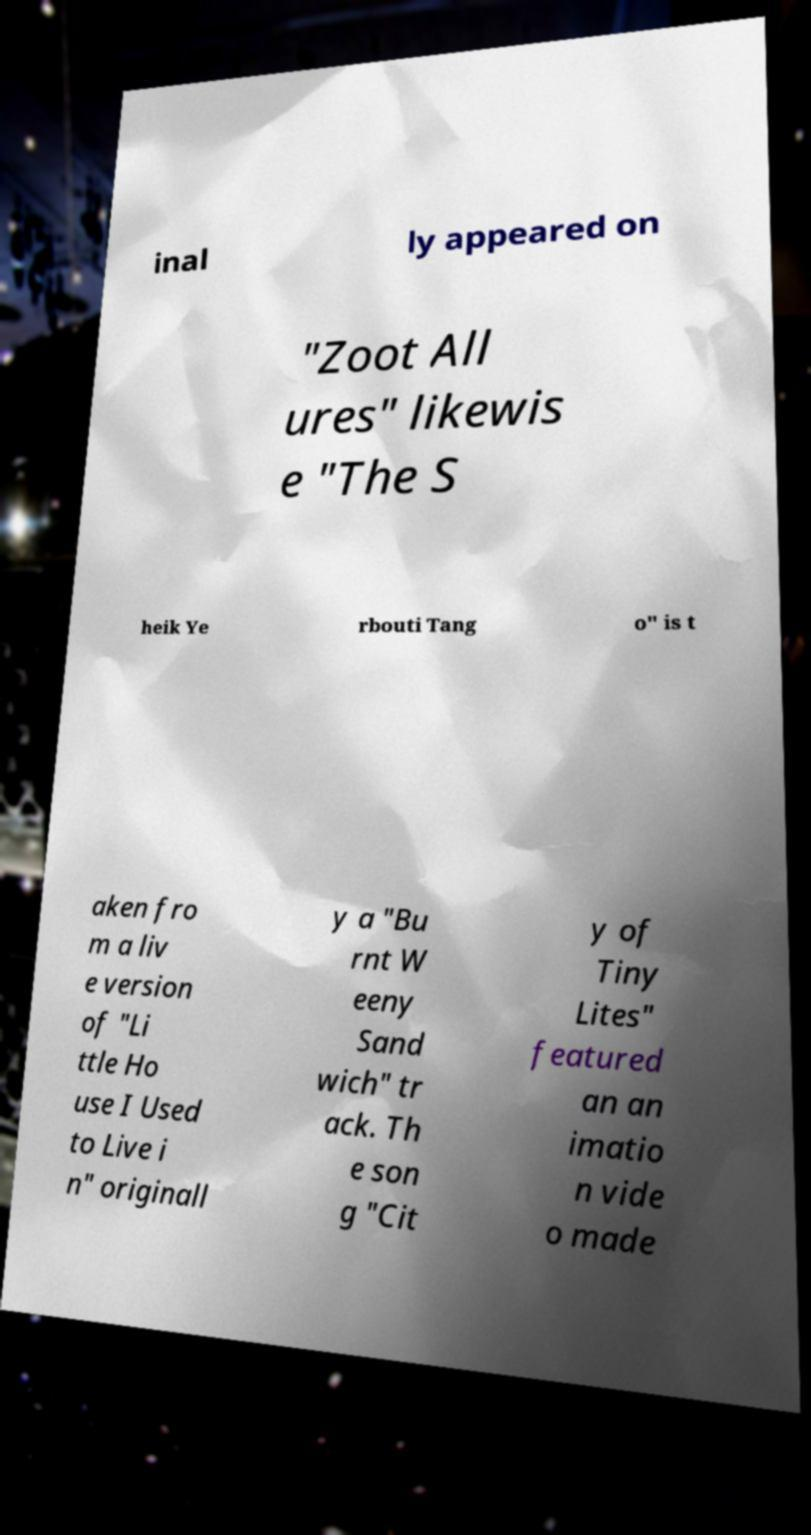I need the written content from this picture converted into text. Can you do that? inal ly appeared on "Zoot All ures" likewis e "The S heik Ye rbouti Tang o" is t aken fro m a liv e version of "Li ttle Ho use I Used to Live i n" originall y a "Bu rnt W eeny Sand wich" tr ack. Th e son g "Cit y of Tiny Lites" featured an an imatio n vide o made 